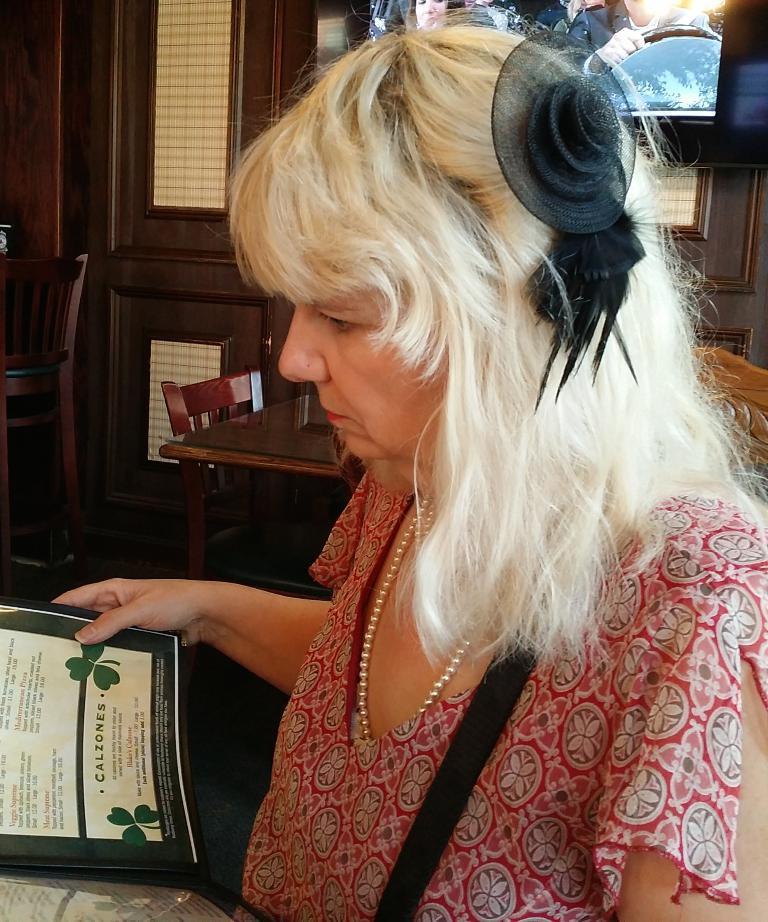Could you give a brief overview of what you see in this image? In this image in front there is a person sitting on the chair and she is holding the menu card. Behind her there is a table. There are chairs. In the background of the image there is a door. There is a TV. 